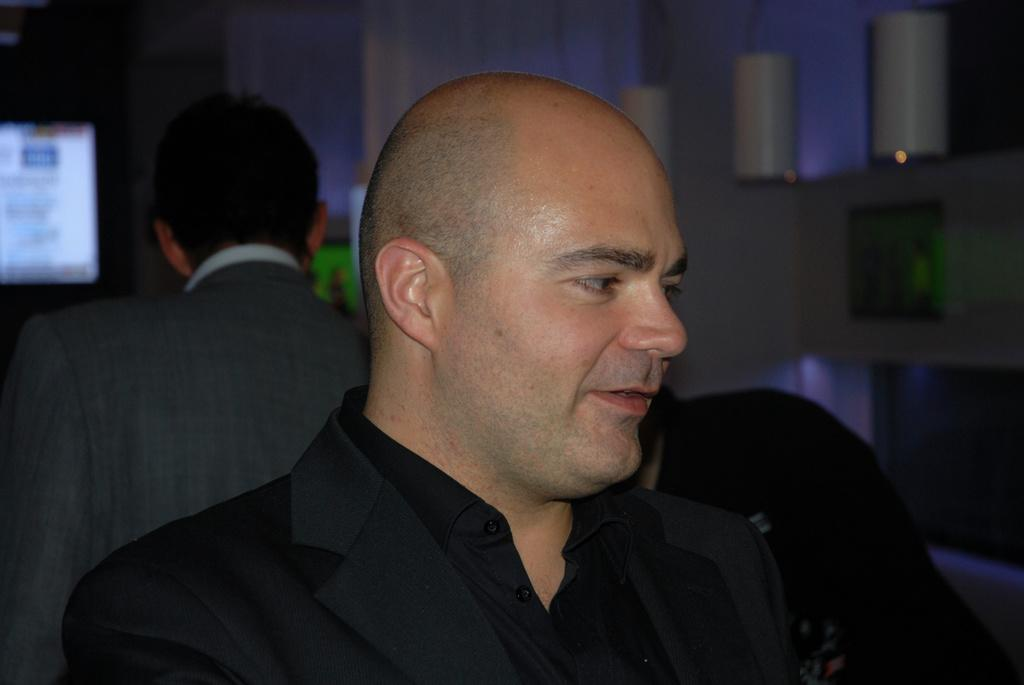What is the appearance of the man in the foreground of the image? There is a man in a black costume standing in the image. Can you describe the position of the second man in the image? There is another man standing behind him in the image. What electronic device is present in the image? There is a TV screen in the image. What type of rub is being applied to the cattle in the image? There are no cattle or rubbing activity present in the image. How many mice can be seen running around in the image? There are no mice present in the image. 